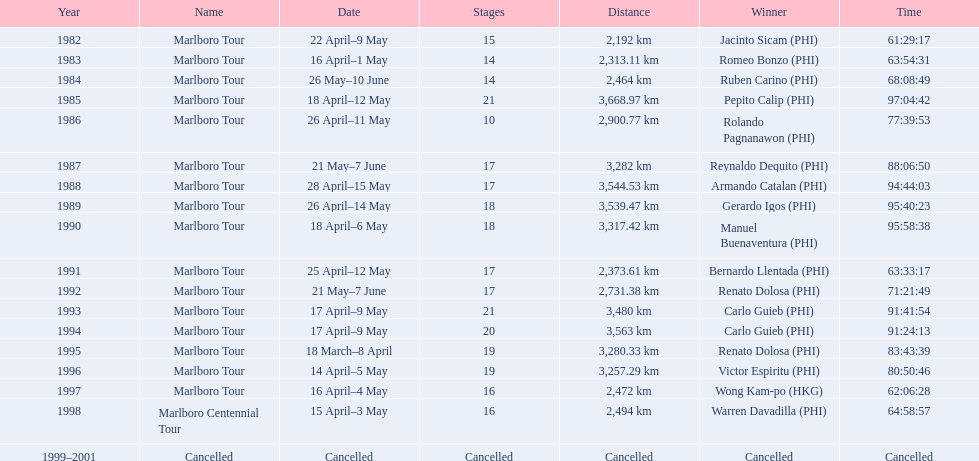Who was the exclusive champion with a time less than 61:45:00? Jacinto Sicam. 